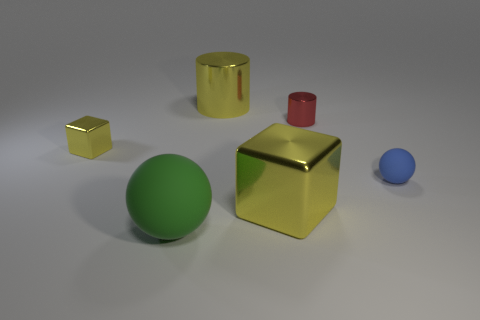Is the number of tiny blue things greater than the number of tiny yellow rubber cubes? No, the number of tiny blue objects is not greater than the number of tiny yellow cubes. In the image, there is only one small blue sphere and two tiny yellow cubes, so the yellow cubes are more numerous. 